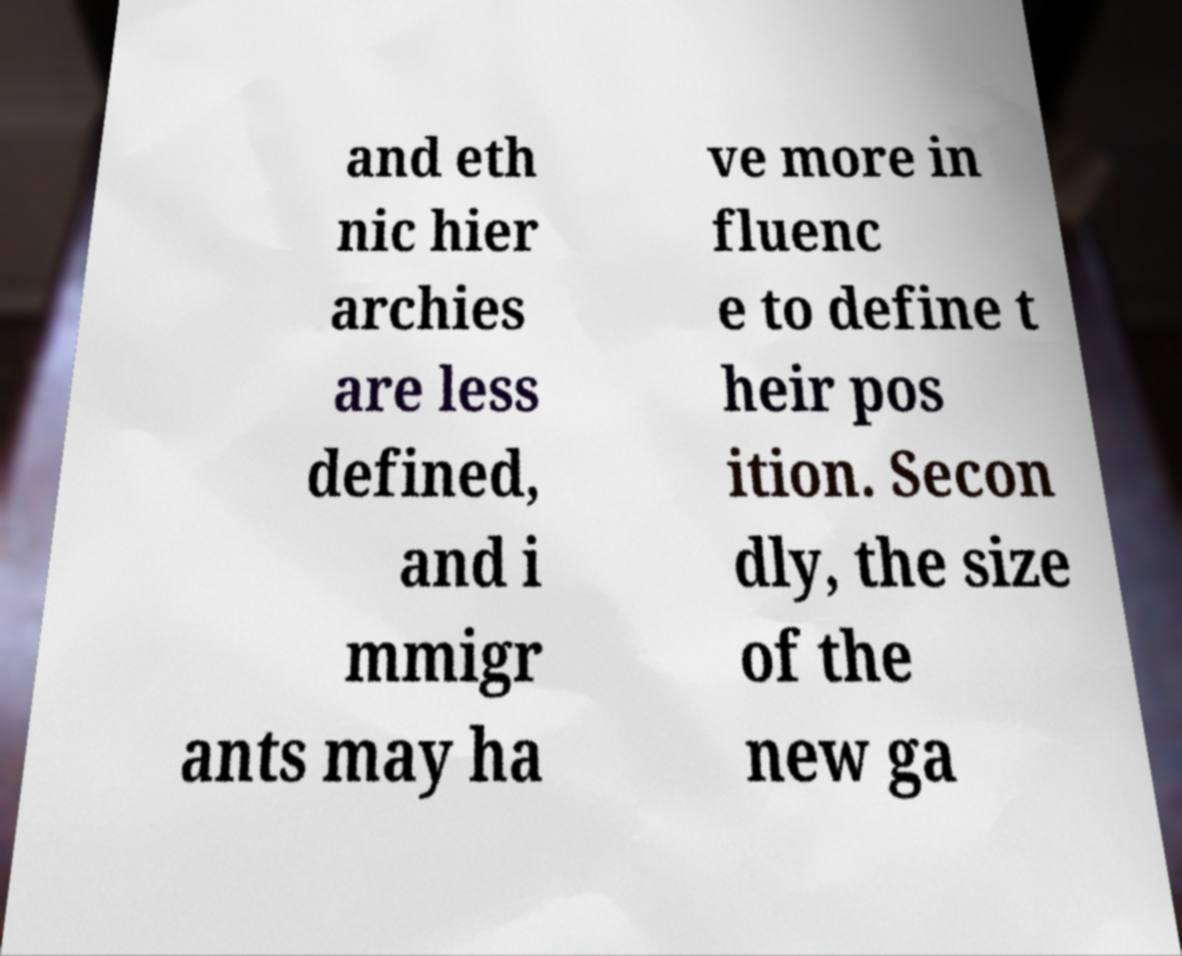Could you assist in decoding the text presented in this image and type it out clearly? and eth nic hier archies are less defined, and i mmigr ants may ha ve more in fluenc e to define t heir pos ition. Secon dly, the size of the new ga 